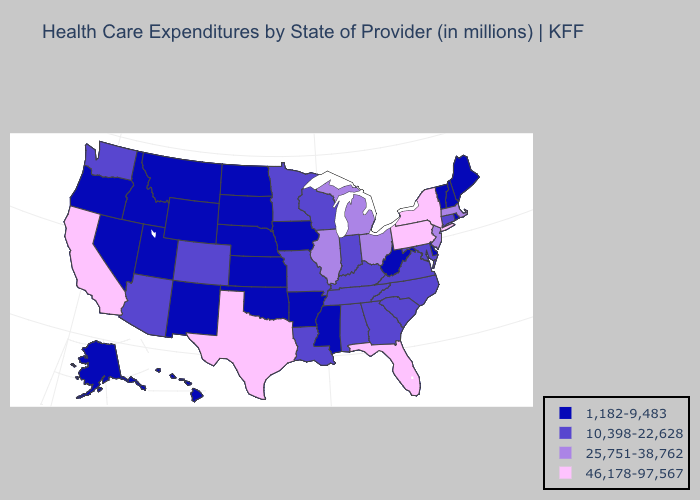Name the states that have a value in the range 1,182-9,483?
Answer briefly. Alaska, Arkansas, Delaware, Hawaii, Idaho, Iowa, Kansas, Maine, Mississippi, Montana, Nebraska, Nevada, New Hampshire, New Mexico, North Dakota, Oklahoma, Oregon, Rhode Island, South Dakota, Utah, Vermont, West Virginia, Wyoming. Which states have the lowest value in the USA?
Quick response, please. Alaska, Arkansas, Delaware, Hawaii, Idaho, Iowa, Kansas, Maine, Mississippi, Montana, Nebraska, Nevada, New Hampshire, New Mexico, North Dakota, Oklahoma, Oregon, Rhode Island, South Dakota, Utah, Vermont, West Virginia, Wyoming. Name the states that have a value in the range 25,751-38,762?
Concise answer only. Illinois, Massachusetts, Michigan, New Jersey, Ohio. What is the highest value in states that border Colorado?
Quick response, please. 10,398-22,628. Among the states that border New Mexico , does Oklahoma have the lowest value?
Short answer required. Yes. Does Oregon have a lower value than Delaware?
Quick response, please. No. Which states have the lowest value in the South?
Answer briefly. Arkansas, Delaware, Mississippi, Oklahoma, West Virginia. What is the highest value in states that border North Dakota?
Write a very short answer. 10,398-22,628. Does the first symbol in the legend represent the smallest category?
Give a very brief answer. Yes. Among the states that border Connecticut , which have the lowest value?
Short answer required. Rhode Island. Name the states that have a value in the range 46,178-97,567?
Short answer required. California, Florida, New York, Pennsylvania, Texas. What is the lowest value in states that border Minnesota?
Keep it brief. 1,182-9,483. Does New Hampshire have the lowest value in the USA?
Give a very brief answer. Yes. What is the lowest value in the USA?
Write a very short answer. 1,182-9,483. What is the value of Michigan?
Write a very short answer. 25,751-38,762. 